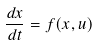<formula> <loc_0><loc_0><loc_500><loc_500>\frac { d x } { d t } = f ( x , u )</formula> 